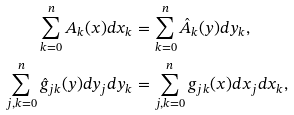Convert formula to latex. <formula><loc_0><loc_0><loc_500><loc_500>\sum _ { k = 0 } ^ { n } A _ { k } ( x ) d x _ { k } & = \sum _ { k = 0 } ^ { n } \hat { A } _ { k } ( y ) d y _ { k } , \\ \sum _ { j , k = 0 } ^ { n } \hat { g } _ { j k } ( y ) d y _ { j } d y _ { k } & = \sum _ { j , k = 0 } ^ { n } g _ { j k } ( x ) d x _ { j } d x _ { k } ,</formula> 